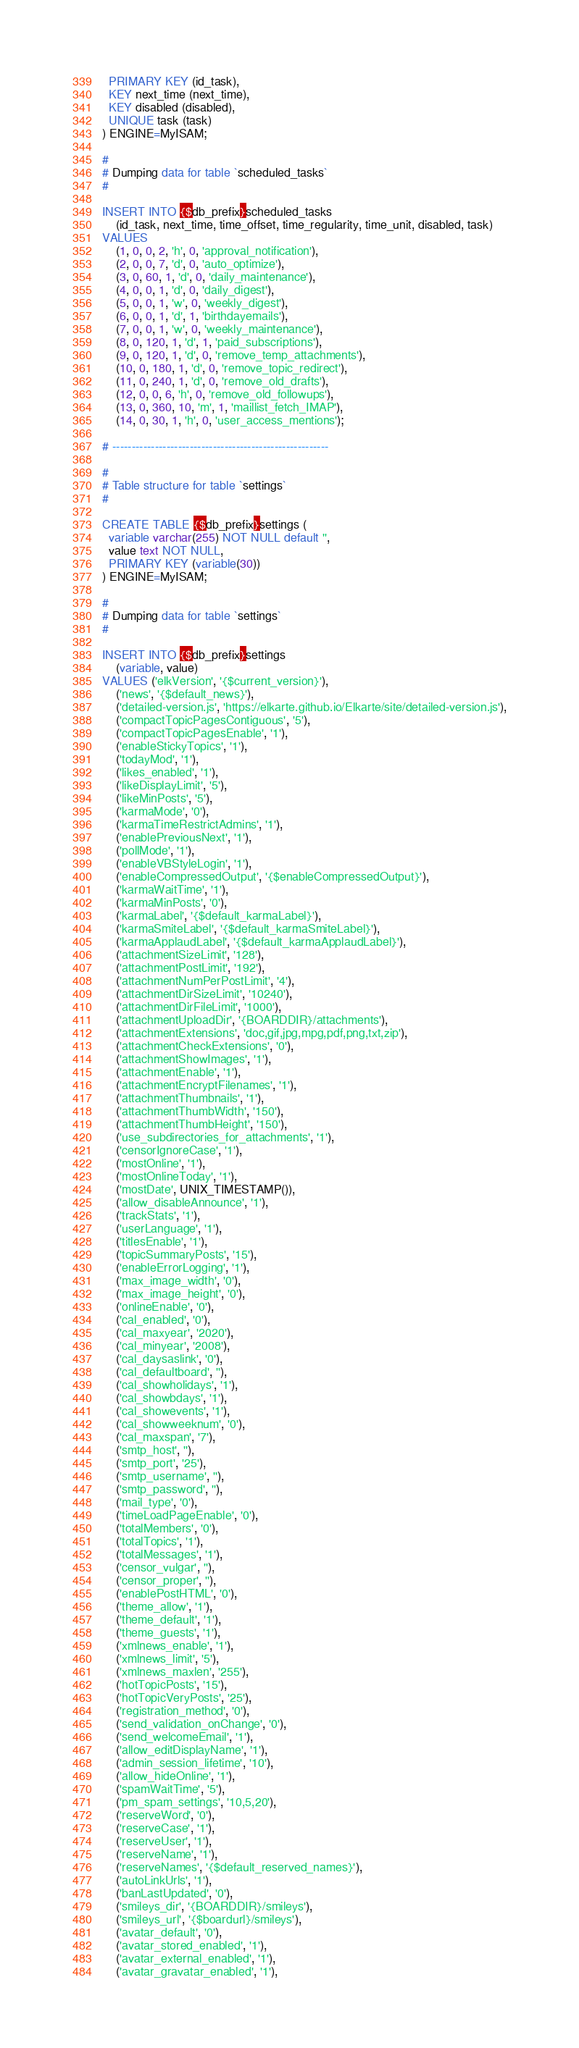Convert code to text. <code><loc_0><loc_0><loc_500><loc_500><_SQL_>  PRIMARY KEY (id_task),
  KEY next_time (next_time),
  KEY disabled (disabled),
  UNIQUE task (task)
) ENGINE=MyISAM;

#
# Dumping data for table `scheduled_tasks`
#

INSERT INTO {$db_prefix}scheduled_tasks
	(id_task, next_time, time_offset, time_regularity, time_unit, disabled, task)
VALUES
	(1, 0, 0, 2, 'h', 0, 'approval_notification'),
	(2, 0, 0, 7, 'd', 0, 'auto_optimize'),
	(3, 0, 60, 1, 'd', 0, 'daily_maintenance'),
	(4, 0, 0, 1, 'd', 0, 'daily_digest'),
	(5, 0, 0, 1, 'w', 0, 'weekly_digest'),
	(6, 0, 0, 1, 'd', 1, 'birthdayemails'),
	(7, 0, 0, 1, 'w', 0, 'weekly_maintenance'),
	(8, 0, 120, 1, 'd', 1, 'paid_subscriptions'),
	(9, 0, 120, 1, 'd', 0, 'remove_temp_attachments'),
	(10, 0, 180, 1, 'd', 0, 'remove_topic_redirect'),
	(11, 0, 240, 1, 'd', 0, 'remove_old_drafts'),
	(12, 0, 0, 6, 'h', 0, 'remove_old_followups'),
	(13, 0, 360, 10, 'm', 1, 'maillist_fetch_IMAP'),
	(14, 0, 30, 1, 'h', 0, 'user_access_mentions');

# --------------------------------------------------------

#
# Table structure for table `settings`
#

CREATE TABLE {$db_prefix}settings (
  variable varchar(255) NOT NULL default '',
  value text NOT NULL,
  PRIMARY KEY (variable(30))
) ENGINE=MyISAM;

#
# Dumping data for table `settings`
#

INSERT INTO {$db_prefix}settings
	(variable, value)
VALUES ('elkVersion', '{$current_version}'),
	('news', '{$default_news}'),
	('detailed-version.js', 'https://elkarte.github.io/Elkarte/site/detailed-version.js'),
	('compactTopicPagesContiguous', '5'),
	('compactTopicPagesEnable', '1'),
	('enableStickyTopics', '1'),
	('todayMod', '1'),
	('likes_enabled', '1'),
	('likeDisplayLimit', '5'),
	('likeMinPosts', '5'),
	('karmaMode', '0'),
	('karmaTimeRestrictAdmins', '1'),
	('enablePreviousNext', '1'),
	('pollMode', '1'),
	('enableVBStyleLogin', '1'),
	('enableCompressedOutput', '{$enableCompressedOutput}'),
	('karmaWaitTime', '1'),
	('karmaMinPosts', '0'),
	('karmaLabel', '{$default_karmaLabel}'),
	('karmaSmiteLabel', '{$default_karmaSmiteLabel}'),
	('karmaApplaudLabel', '{$default_karmaApplaudLabel}'),
	('attachmentSizeLimit', '128'),
	('attachmentPostLimit', '192'),
	('attachmentNumPerPostLimit', '4'),
	('attachmentDirSizeLimit', '10240'),
	('attachmentDirFileLimit', '1000'),
	('attachmentUploadDir', '{BOARDDIR}/attachments'),
	('attachmentExtensions', 'doc,gif,jpg,mpg,pdf,png,txt,zip'),
	('attachmentCheckExtensions', '0'),
	('attachmentShowImages', '1'),
	('attachmentEnable', '1'),
	('attachmentEncryptFilenames', '1'),
	('attachmentThumbnails', '1'),
	('attachmentThumbWidth', '150'),
	('attachmentThumbHeight', '150'),
	('use_subdirectories_for_attachments', '1'),
	('censorIgnoreCase', '1'),
	('mostOnline', '1'),
	('mostOnlineToday', '1'),
	('mostDate', UNIX_TIMESTAMP()),
	('allow_disableAnnounce', '1'),
	('trackStats', '1'),
	('userLanguage', '1'),
	('titlesEnable', '1'),
	('topicSummaryPosts', '15'),
	('enableErrorLogging', '1'),
	('max_image_width', '0'),
	('max_image_height', '0'),
	('onlineEnable', '0'),
	('cal_enabled', '0'),
	('cal_maxyear', '2020'),
	('cal_minyear', '2008'),
	('cal_daysaslink', '0'),
	('cal_defaultboard', ''),
	('cal_showholidays', '1'),
	('cal_showbdays', '1'),
	('cal_showevents', '1'),
	('cal_showweeknum', '0'),
	('cal_maxspan', '7'),
	('smtp_host', ''),
	('smtp_port', '25'),
	('smtp_username', ''),
	('smtp_password', ''),
	('mail_type', '0'),
	('timeLoadPageEnable', '0'),
	('totalMembers', '0'),
	('totalTopics', '1'),
	('totalMessages', '1'),
	('censor_vulgar', ''),
	('censor_proper', ''),
	('enablePostHTML', '0'),
	('theme_allow', '1'),
	('theme_default', '1'),
	('theme_guests', '1'),
	('xmlnews_enable', '1'),
	('xmlnews_limit', '5'),
	('xmlnews_maxlen', '255'),
	('hotTopicPosts', '15'),
	('hotTopicVeryPosts', '25'),
	('registration_method', '0'),
	('send_validation_onChange', '0'),
	('send_welcomeEmail', '1'),
	('allow_editDisplayName', '1'),
	('admin_session_lifetime', '10'),
	('allow_hideOnline', '1'),
	('spamWaitTime', '5'),
	('pm_spam_settings', '10,5,20'),
	('reserveWord', '0'),
	('reserveCase', '1'),
	('reserveUser', '1'),
	('reserveName', '1'),
	('reserveNames', '{$default_reserved_names}'),
	('autoLinkUrls', '1'),
	('banLastUpdated', '0'),
	('smileys_dir', '{BOARDDIR}/smileys'),
	('smileys_url', '{$boardurl}/smileys'),
	('avatar_default', '0'),
	('avatar_stored_enabled', '1'),
	('avatar_external_enabled', '1'),
	('avatar_gravatar_enabled', '1'),</code> 